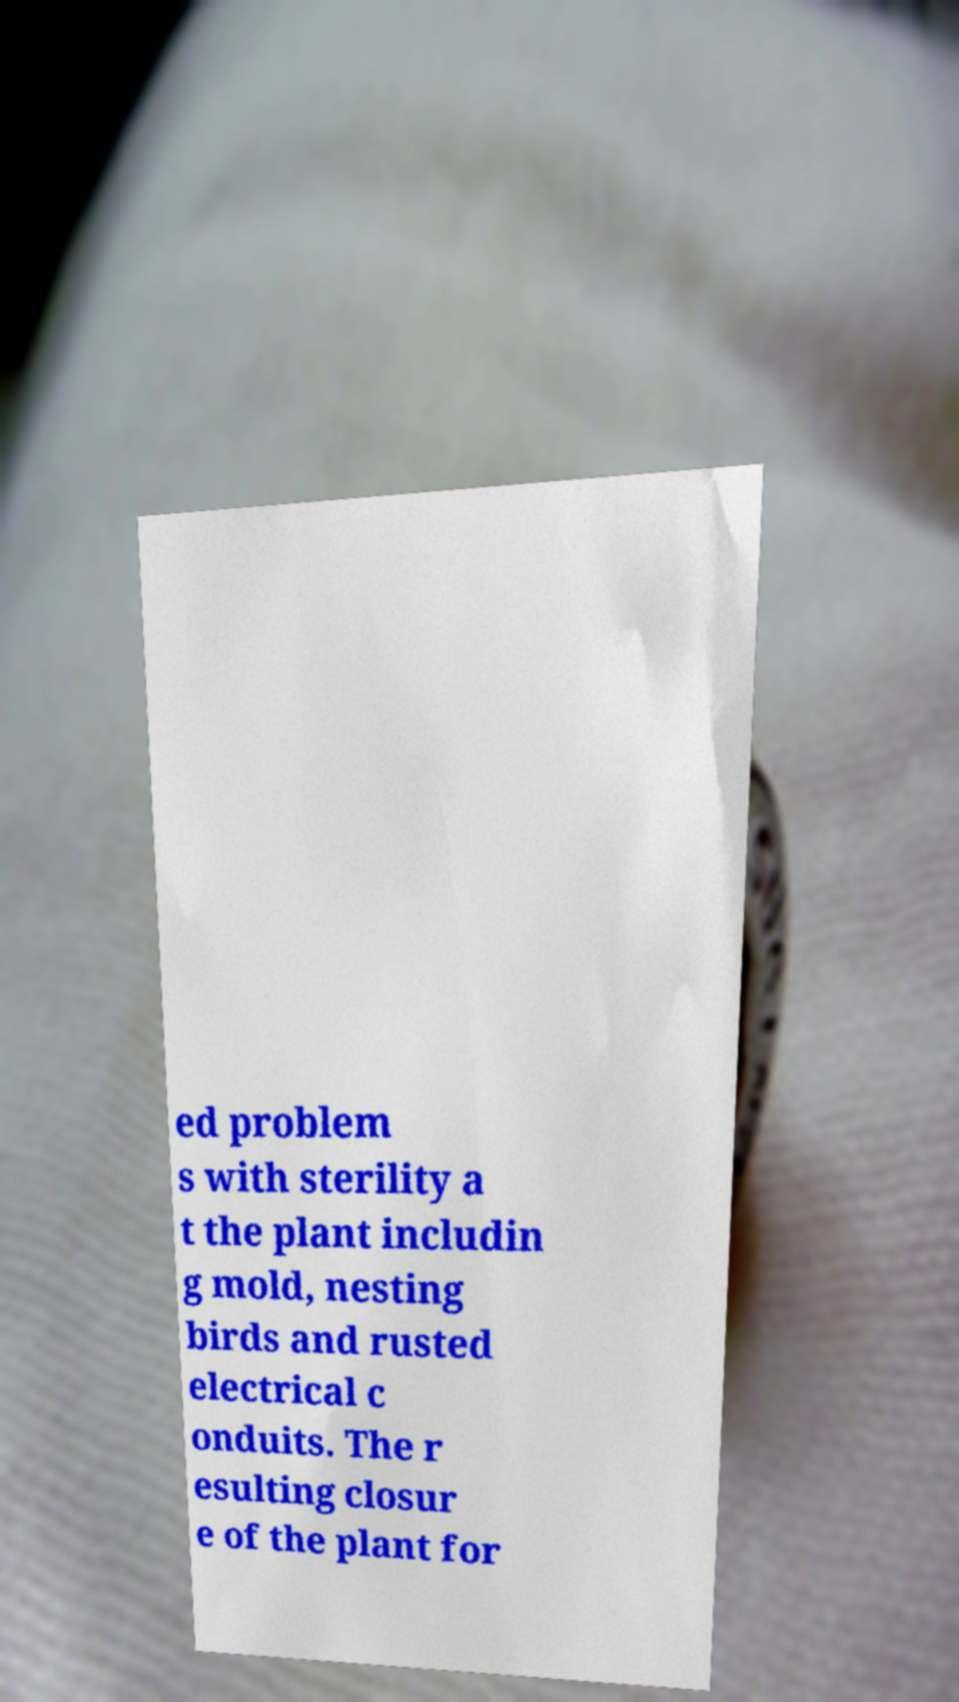What messages or text are displayed in this image? I need them in a readable, typed format. ed problem s with sterility a t the plant includin g mold, nesting birds and rusted electrical c onduits. The r esulting closur e of the plant for 